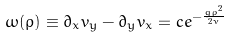Convert formula to latex. <formula><loc_0><loc_0><loc_500><loc_500>\omega ( \rho ) \equiv \partial _ { x } v _ { y } - \partial _ { y } v _ { x } = c e ^ { - \frac { g \rho ^ { 2 } } { 2 \nu } }</formula> 